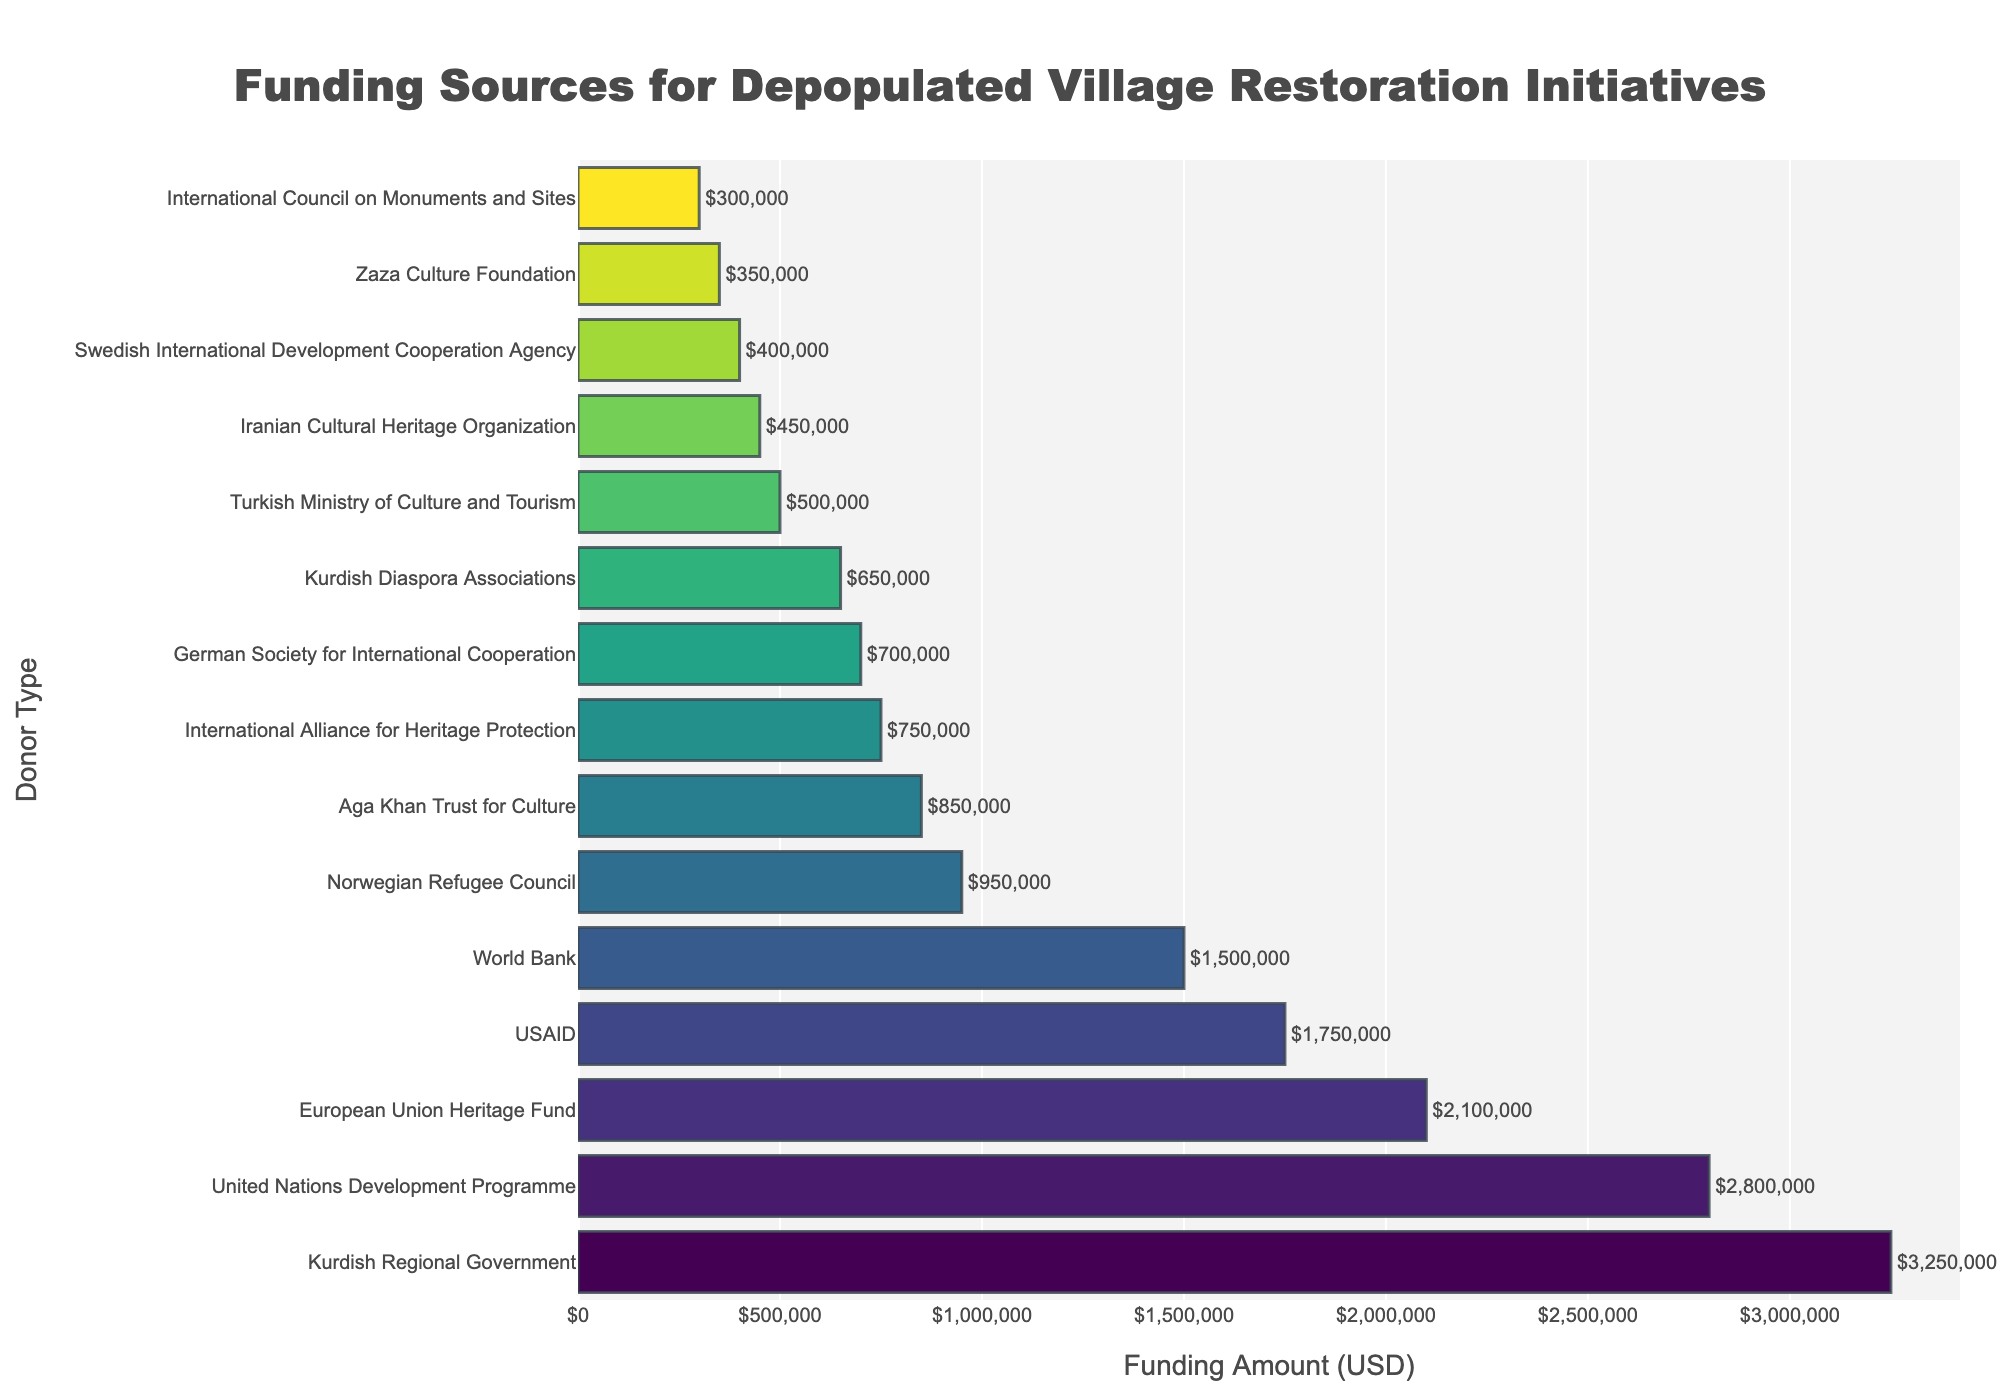Which donor provided the highest funding amount? The bar representing the "Kurdish Regional Government" is the longest on the chart, indicating it provided the highest funding amount. The precise figure is labeled as $3,250,000.
Answer: Kurdish Regional Government What is the total funding amount from the Kurdish Diaspora Associations and the Zaza Culture Foundation? Add the funding amounts provided by the Kurdish Diaspora Associations ($650,000) and the Zaza Culture Foundation ($350,000). Therefore, the total funding is $650,000 + $350,000 = $1,000,000.
Answer: $1,000,000 Which donor contributed less funding: USAID or the European Union Heritage Fund? Compare the lengths of the bars for USAID ($1,750,000) and the European Union Heritage Fund ($2,100,000). The shorter bar is for USAID, showing it contributed less.
Answer: USAID How much more funding did the United Nations Development Programme provide compared to the World Bank? The United Nations Development Programme provided $2,800,000, while the World Bank provided $1,500,000. The difference is $2,800,000 - $1,500,000 = $1,300,000.
Answer: $1,300,000 What is the total funding amount provided by the top three donors? Sum the funding amounts provided by the top three donors: Kurdish Regional Government ($3,250,000), United Nations Development Programme ($2,800,000), and European Union Heritage Fund ($2,100,000). The total is $3,250,000 + $2,800,000 + $2,100,000 = $8,150,000.
Answer: $8,150,000 What is the average funding amount contributed by the listed donors? Sum all the funding amounts and divide by the number of donors. The total funding is $3250000 + $2800000 + $2100000 + $1750000 + $1500000 + $950000 + $850000 + $750000 + $700000 + $650000 + $500000 + $450000 + $400000 + $350000 + $300000 = $15850000. There are 15 donors, so the average is $15,850,000 / 15 = $1,056,666.67.
Answer: $1,056,666.67 Which funding source's contribution is closest to the visual center of the chart? Look for the bar positioned approximately in the middle of the y-axis. The Norwegian Refugee Council is near the center and contributed $950,000.
Answer: Norwegian Refugee Council How many donors contributed an amount less than $1,000,000? Count the bars with funding amounts less than $1,000,000. These are the Norwegian Refugee Council, Aga Khan Trust for Culture, International Alliance for Heritage Protection, German Society for International Cooperation, Kurdish Diaspora Associations, Turkish Ministry of Culture and Tourism, Iranian Cultural Heritage Organization, Swedish International Development Cooperation Agency, Zaza Culture Foundation, and International Council on Monuments and Sites. This totals to 10 donors.
Answer: 10 By how much does the Kurdish Regional Government's funding exceed the sum of the funding provided by the German Society for International Cooperation and the Swedish International Development Cooperation Agency? First, sum the funding from the German Society for International Cooperation ($700,000) and the Swedish International Development Cooperation Agency ($400,000), which equals $1,100,000. Then, subtract this from the Kurdish Regional Government's funding, $3,250,000 - $1,100,000 = $2,150,000.
Answer: $2,150,000 